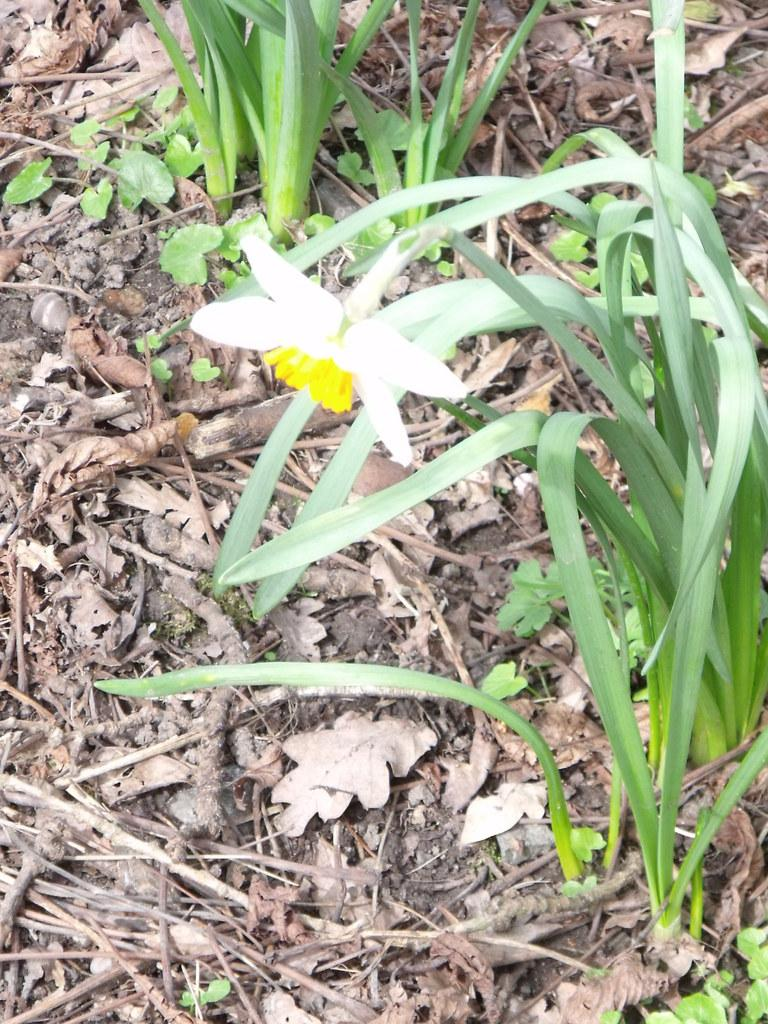What type of plants can be seen in the image? There are plants with flowers in the image. What can be found on the path in the image? There are dry leaves and stems on the path in the image. What advertisement can be seen on the plants in the image? There is no advertisement present on the plants in the image. What is the weight of the flock of birds flying over the plants in the image? There are no birds present in the image, so it is not possible to determine the weight of a flock of birds. 